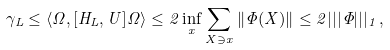Convert formula to latex. <formula><loc_0><loc_0><loc_500><loc_500>\gamma _ { L } \leq \langle \Omega , [ H _ { L } , U ] \Omega \rangle \leq 2 \inf _ { x } \sum _ { X \ni x } \| \Phi ( X ) \| \leq 2 | | | \Phi | | | _ { 1 } \, ,</formula> 